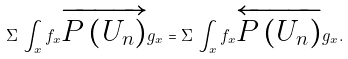Convert formula to latex. <formula><loc_0><loc_0><loc_500><loc_500>\Sigma \, \int _ { x } f _ { x } \overrightarrow { P \left ( U _ { n } \right ) } g _ { x } = \Sigma \, \int _ { x } f _ { x } \overleftarrow { P \left ( U _ { n } \right ) } g _ { x } .</formula> 